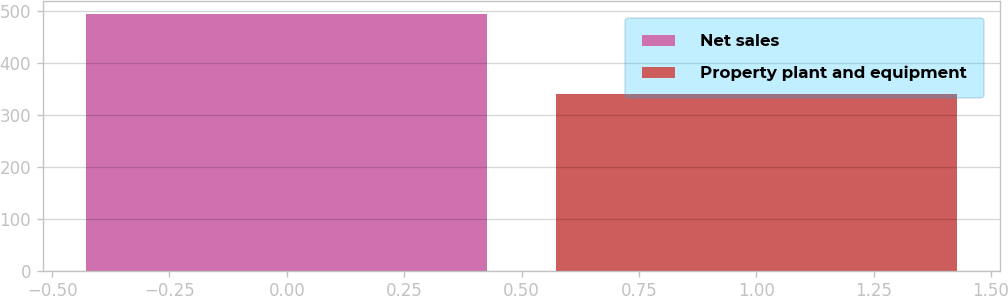Convert chart to OTSL. <chart><loc_0><loc_0><loc_500><loc_500><bar_chart><fcel>Net sales<fcel>Property plant and equipment<nl><fcel>494.3<fcel>339.3<nl></chart> 